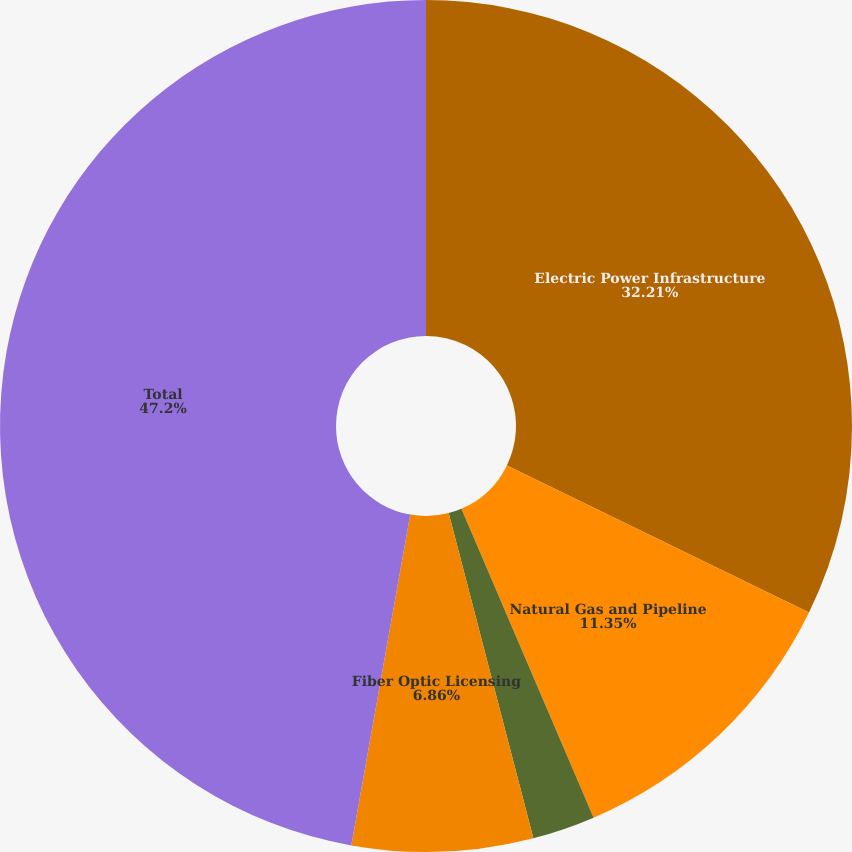Convert chart to OTSL. <chart><loc_0><loc_0><loc_500><loc_500><pie_chart><fcel>Electric Power Infrastructure<fcel>Natural Gas and Pipeline<fcel>Telecommunications<fcel>Fiber Optic Licensing<fcel>Total<nl><fcel>32.21%<fcel>11.35%<fcel>2.38%<fcel>6.86%<fcel>47.19%<nl></chart> 